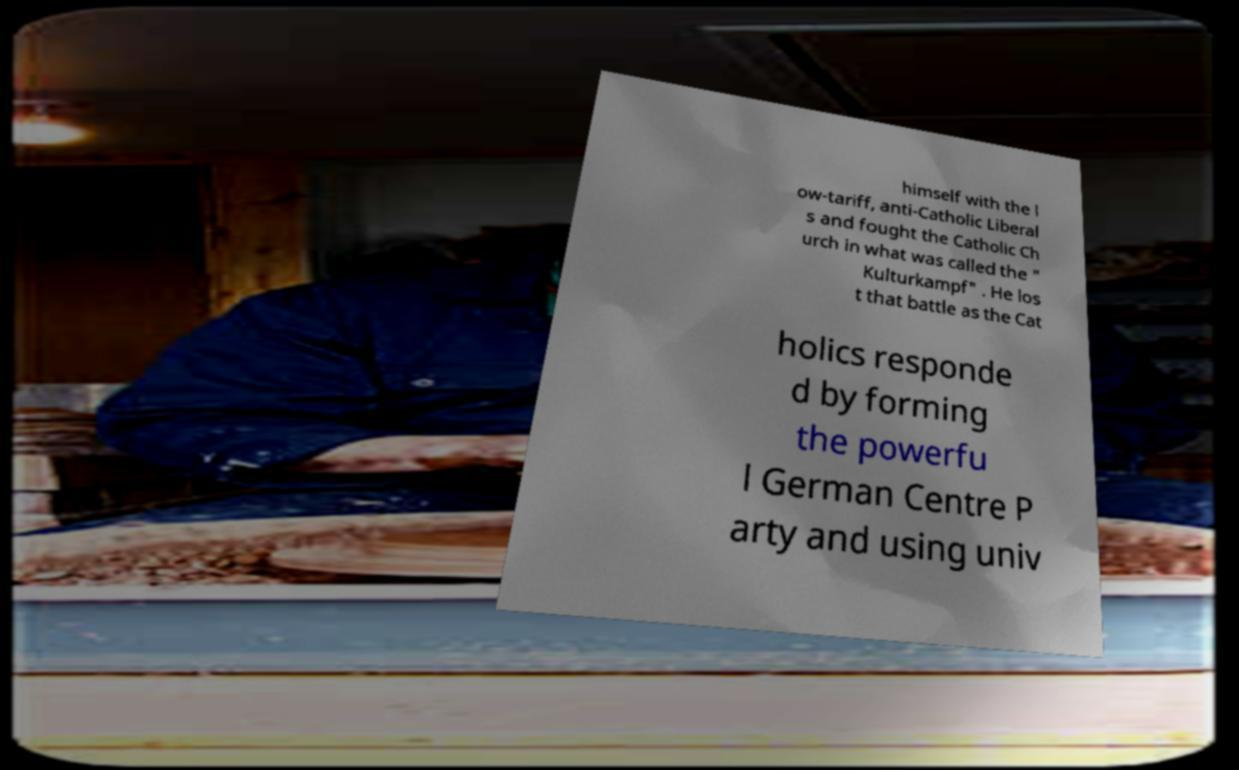I need the written content from this picture converted into text. Can you do that? himself with the l ow-tariff, anti-Catholic Liberal s and fought the Catholic Ch urch in what was called the " Kulturkampf" . He los t that battle as the Cat holics responde d by forming the powerfu l German Centre P arty and using univ 